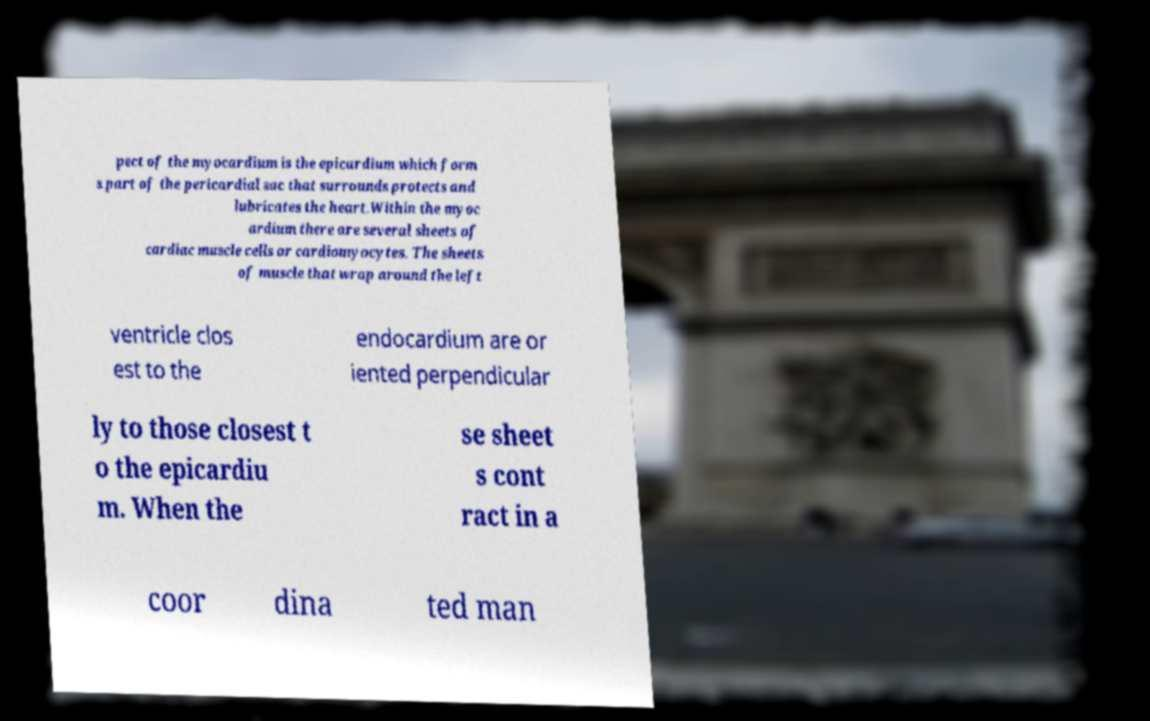Please identify and transcribe the text found in this image. pect of the myocardium is the epicardium which form s part of the pericardial sac that surrounds protects and lubricates the heart.Within the myoc ardium there are several sheets of cardiac muscle cells or cardiomyocytes. The sheets of muscle that wrap around the left ventricle clos est to the endocardium are or iented perpendicular ly to those closest t o the epicardiu m. When the se sheet s cont ract in a coor dina ted man 